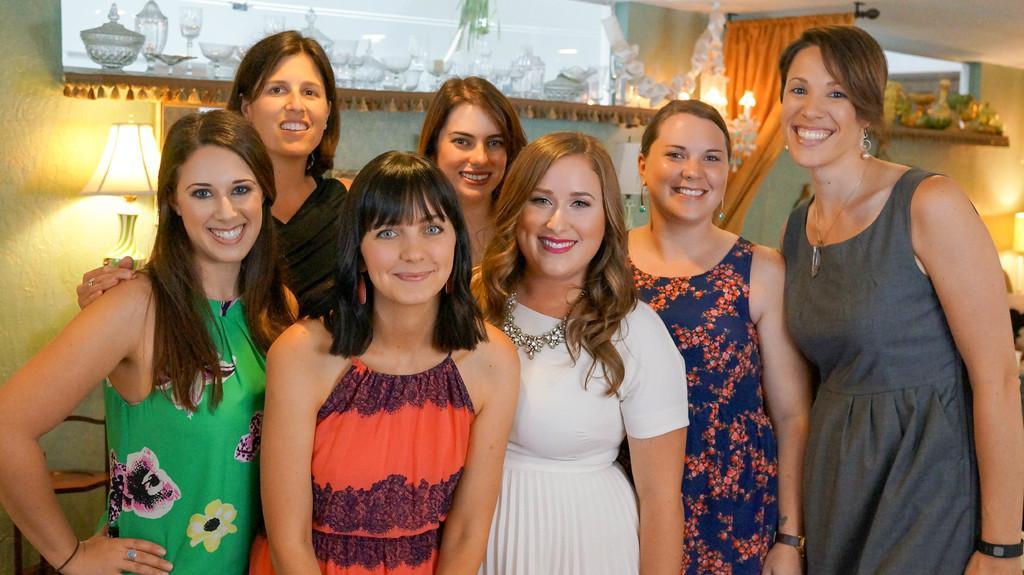Please provide a concise description of this image. In front of the picture, we see seven women are standing. All of them are smiling and they are posing for the photo. Behind them, we see a rack in which glasses and glass bowls are placed. Beside that, we see the candles and the curtain in orange color. Behind them, we see a wall and the lamp. In the top right, we see a rack in which some objects are placed. On the right side, we see the lamp. 